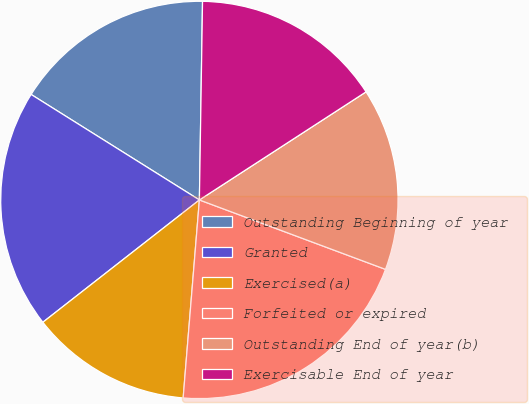<chart> <loc_0><loc_0><loc_500><loc_500><pie_chart><fcel>Outstanding Beginning of year<fcel>Granted<fcel>Exercised(a)<fcel>Forfeited or expired<fcel>Outstanding End of year(b)<fcel>Exercisable End of year<nl><fcel>16.34%<fcel>19.47%<fcel>13.14%<fcel>20.62%<fcel>14.84%<fcel>15.59%<nl></chart> 